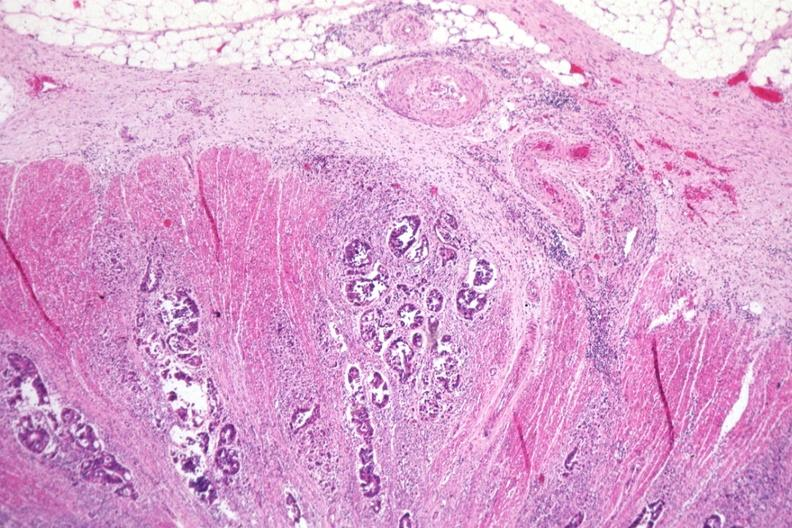s colon present?
Answer the question using a single word or phrase. Yes 